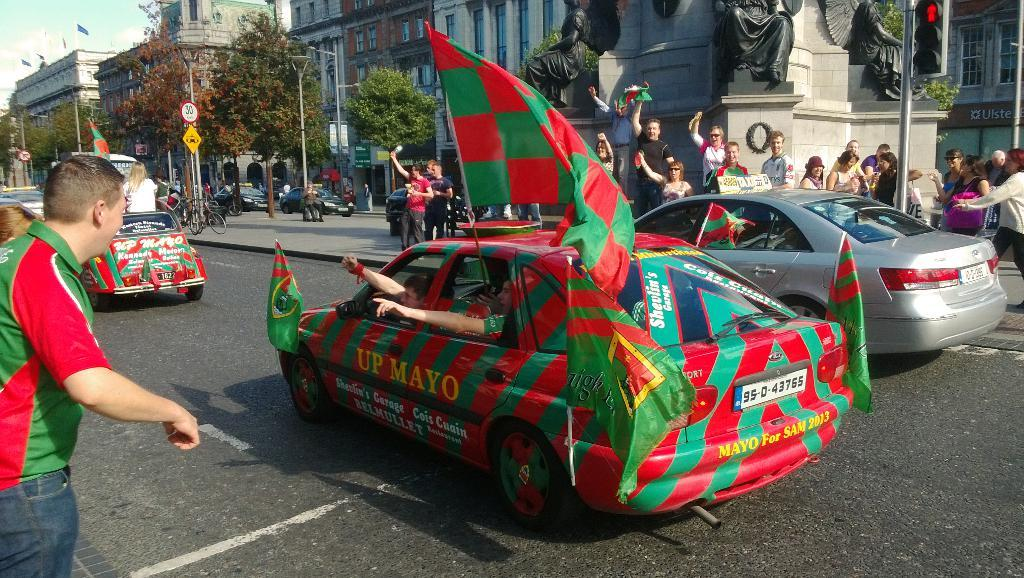What are the people in the car doing? The people in the car are holding a flag. What can be seen in the background of the image? There are buildings and trees in the image. What type of orange is being used as a prop in the image? There is no orange present in the image. How much lettuce can be seen growing in the image? There is no lettuce present in the image, nor is there any indication of growth. 